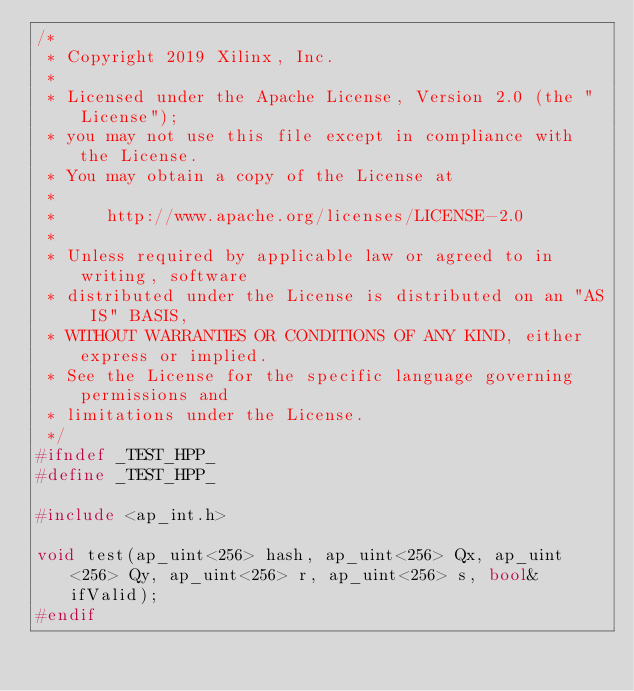<code> <loc_0><loc_0><loc_500><loc_500><_C++_>/*
 * Copyright 2019 Xilinx, Inc.
 *
 * Licensed under the Apache License, Version 2.0 (the "License");
 * you may not use this file except in compliance with the License.
 * You may obtain a copy of the License at
 *
 *     http://www.apache.org/licenses/LICENSE-2.0
 *
 * Unless required by applicable law or agreed to in writing, software
 * distributed under the License is distributed on an "AS IS" BASIS,
 * WITHOUT WARRANTIES OR CONDITIONS OF ANY KIND, either express or implied.
 * See the License for the specific language governing permissions and
 * limitations under the License.
 */
#ifndef _TEST_HPP_
#define _TEST_HPP_

#include <ap_int.h>

void test(ap_uint<256> hash, ap_uint<256> Qx, ap_uint<256> Qy, ap_uint<256> r, ap_uint<256> s, bool& ifValid);
#endif
</code> 